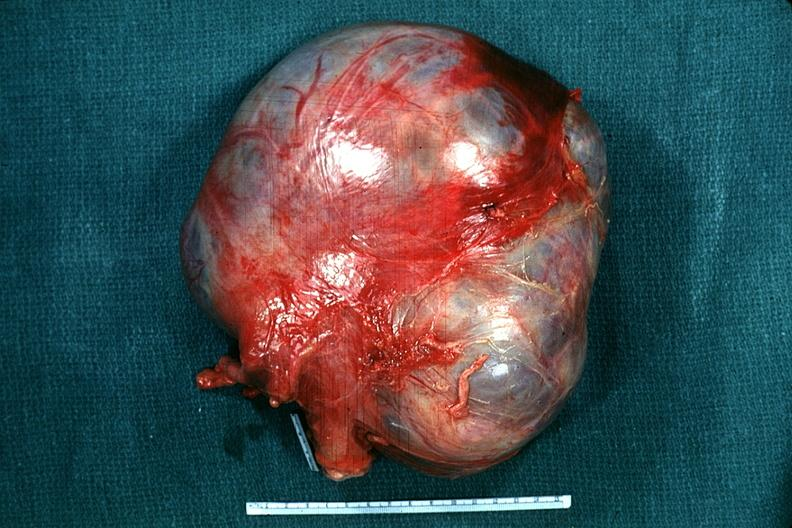does quite good liver show external view typical appearance?
Answer the question using a single word or phrase. No 